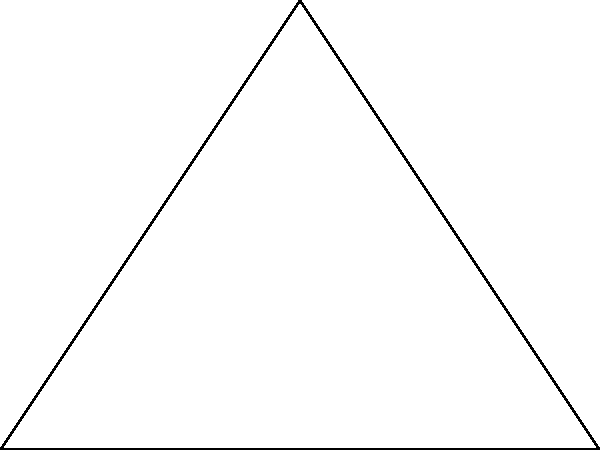For a new sci-fi exhibit featuring triangular spacecraft, you need to calculate the dimensions of a ship. The spacecraft has a right-angled triangle shape with a perimeter of 12 km. One of the other angles is 60°. What is the length of the longest side (hypotenuse) of the spacecraft? Let's approach this step-by-step:

1) In a right-angled triangle, if one angle is 60°, the other non-right angle must be 30° (as the angles in a triangle sum to 180°).

2) In a 30-60-90 triangle, if we denote the shortest side as $x$, then the other sides are:
   - Shortest side: $x$
   - Middle side: $x\sqrt{3}$
   - Longest side (hypotenuse): $2x$

3) We know the perimeter is 12 km. So we can write an equation:
   $x + x\sqrt{3} + 2x = 12$

4) Simplify:
   $x(1 + \sqrt{3} + 2) = 12$
   $x(3 + \sqrt{3}) = 12$

5) Solve for $x$:
   $x = \frac{12}{3 + \sqrt{3}}$

6) The longest side (hypotenuse) is $2x$, so:
   Longest side $= 2 \cdot \frac{12}{3 + \sqrt{3}} = \frac{24}{3 + \sqrt{3}}$

7) Simplify:
   $\frac{24}{3 + \sqrt{3}} \cdot \frac{3 - \sqrt{3}}{3 - \sqrt{3}} = \frac{24(3 - \sqrt{3})}{9 - 3} = \frac{24(3 - \sqrt{3})}{6} = 4(3 - \sqrt{3})$

Therefore, the length of the longest side is $4(3 - \sqrt{3})$ km.
Answer: $4(3 - \sqrt{3})$ km 